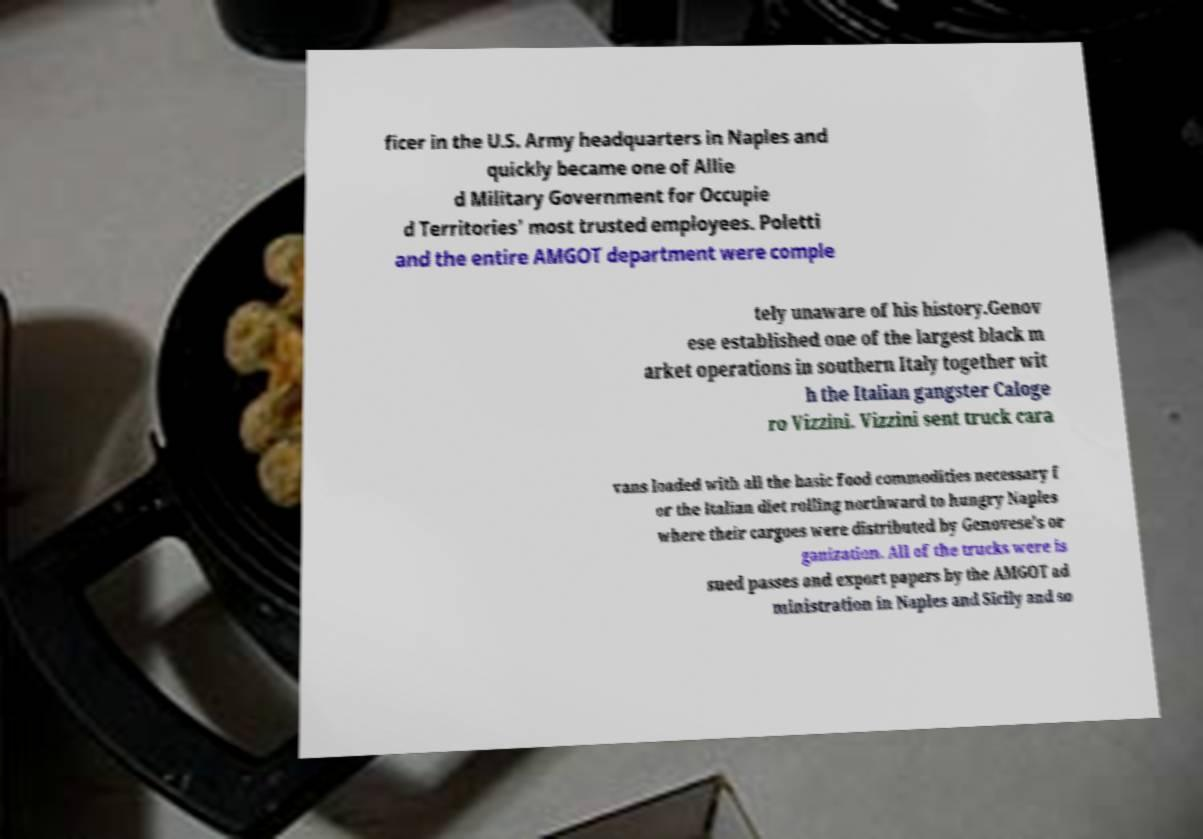Could you extract and type out the text from this image? ficer in the U.S. Army headquarters in Naples and quickly became one of Allie d Military Government for Occupie d Territories' most trusted employees. Poletti and the entire AMGOT department were comple tely unaware of his history.Genov ese established one of the largest black m arket operations in southern Italy together wit h the Italian gangster Caloge ro Vizzini. Vizzini sent truck cara vans loaded with all the basic food commodities necessary f or the Italian diet rolling northward to hungry Naples where their cargoes were distributed by Genovese's or ganization. All of the trucks were is sued passes and export papers by the AMGOT ad ministration in Naples and Sicily and so 